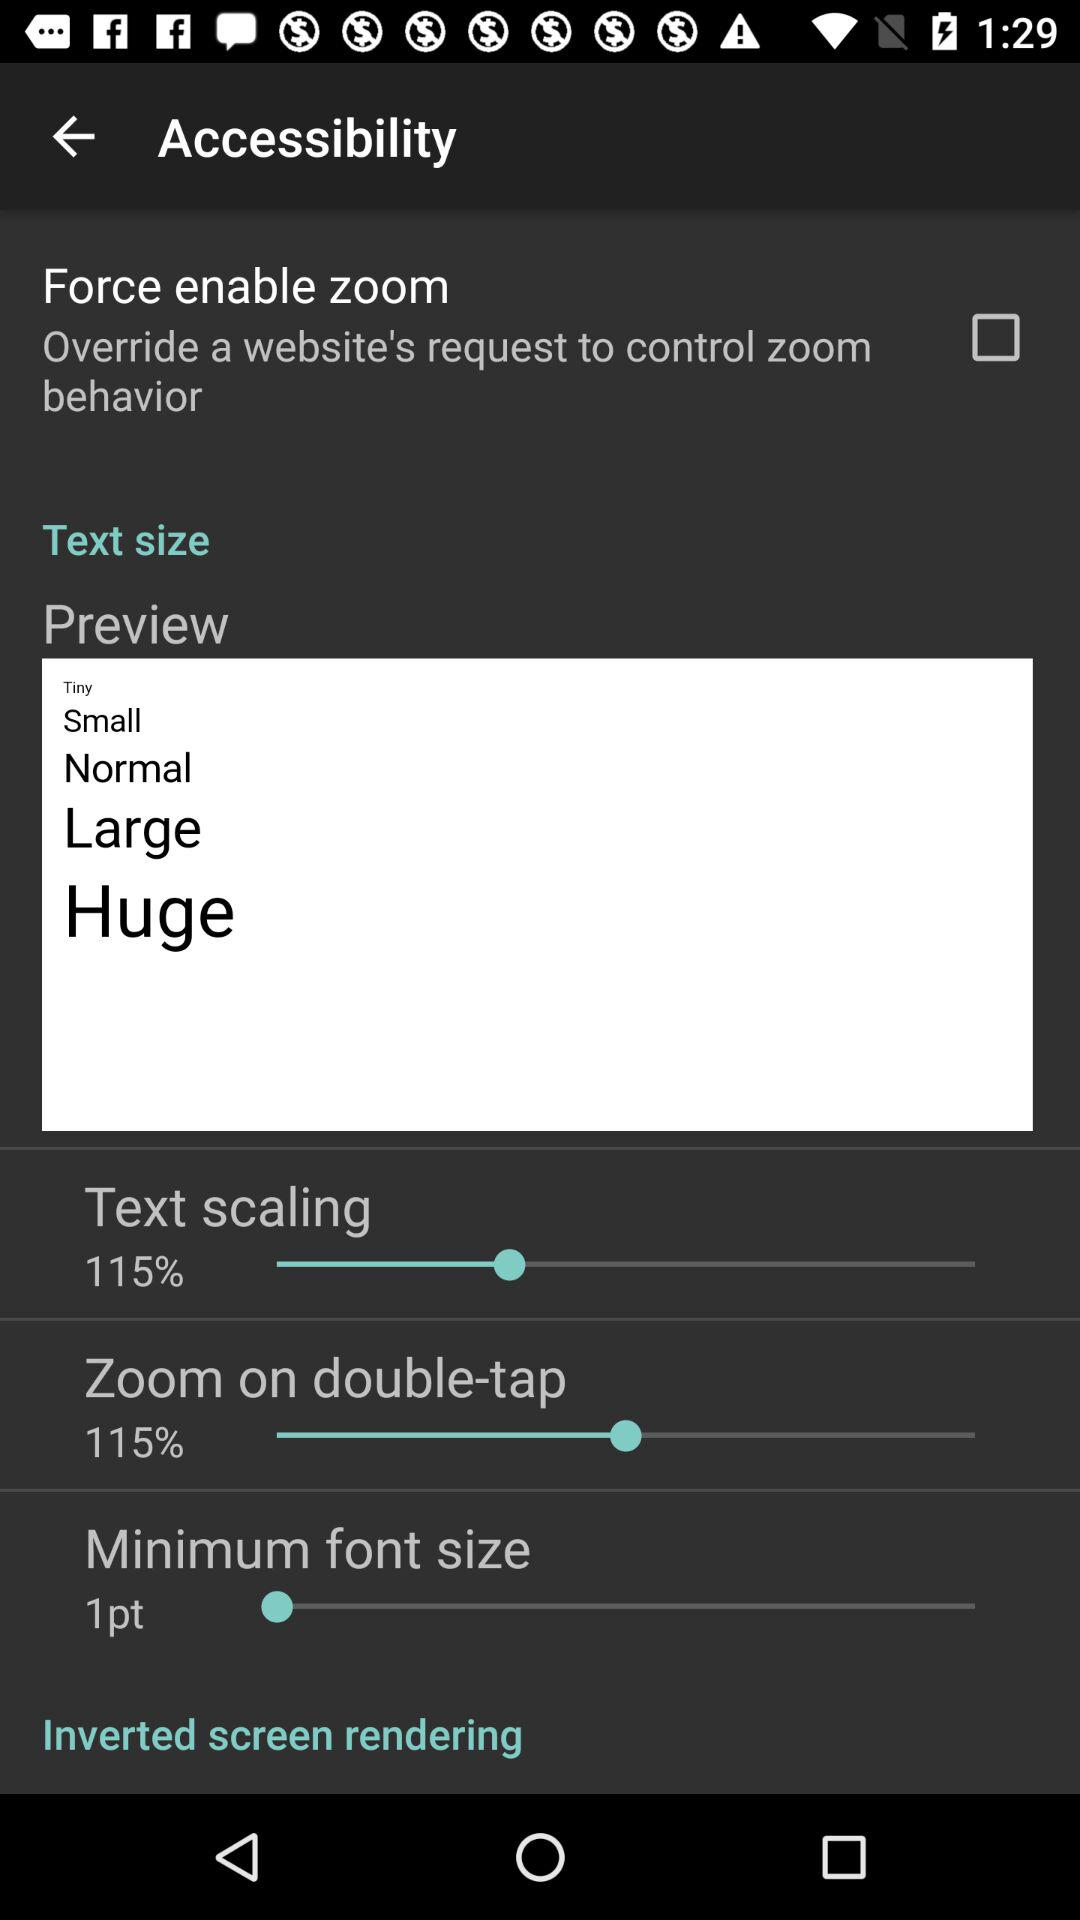What is the text size of the text 'Zoom on double-tap'?
Answer the question using a single word or phrase. 115% 